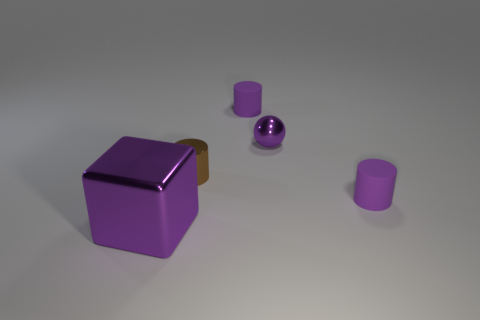There is a purple shiny thing that is behind the shiny cube; does it have the same size as the purple rubber object on the right side of the sphere?
Make the answer very short. Yes. What is the purple thing that is in front of the tiny shiny cylinder and behind the metal cube made of?
Ensure brevity in your answer.  Rubber. How many purple rubber cylinders are behind the large object?
Provide a short and direct response. 2. Is there anything else that is the same size as the block?
Your response must be concise. No. The tiny thing that is made of the same material as the purple ball is what color?
Ensure brevity in your answer.  Brown. Is the large purple thing the same shape as the brown object?
Provide a succinct answer. No. What number of metal objects are both in front of the tiny brown metal thing and behind the big purple shiny object?
Ensure brevity in your answer.  0. How many metal things are either balls or small purple things?
Provide a succinct answer. 1. There is a matte thing right of the purple metal object that is to the right of the purple metallic cube; what size is it?
Ensure brevity in your answer.  Small. There is a small sphere that is the same color as the block; what material is it?
Your answer should be compact. Metal. 